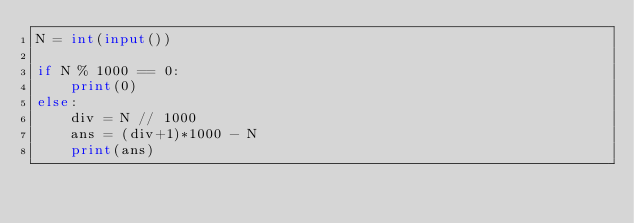Convert code to text. <code><loc_0><loc_0><loc_500><loc_500><_Python_>N = int(input())

if N % 1000 == 0:
    print(0)
else:
    div = N // 1000
    ans = (div+1)*1000 - N
    print(ans)</code> 